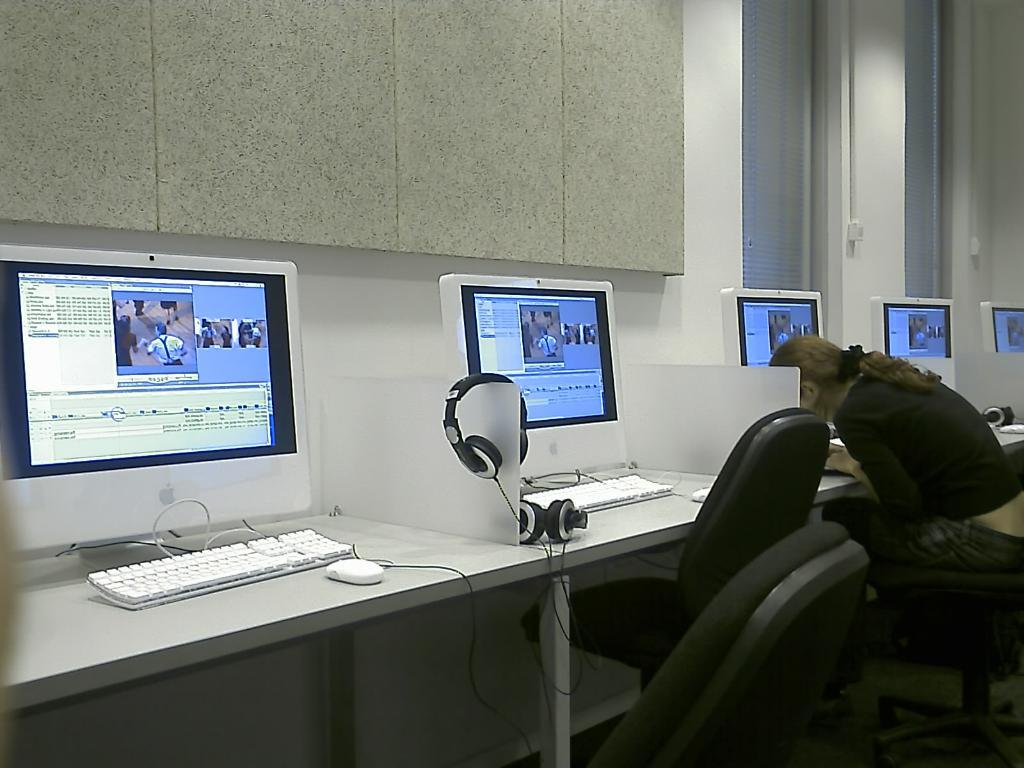How many screens are visible in the image? There are five screens in the image. What objects are on the table in the image? There are keyboards on the table. Can you describe the person in the image? A woman is sitting in the image. How many chairs are in the image? There are two chairs in the image. What can be seen in the background of the image? There is a wall in the background of the image. Are there any bears or ladybugs visible in the image? No, there are no bears or ladybugs present in the image. What type of meal is being prepared or served in the image? There is no indication of any meal preparation or serving in the image. 